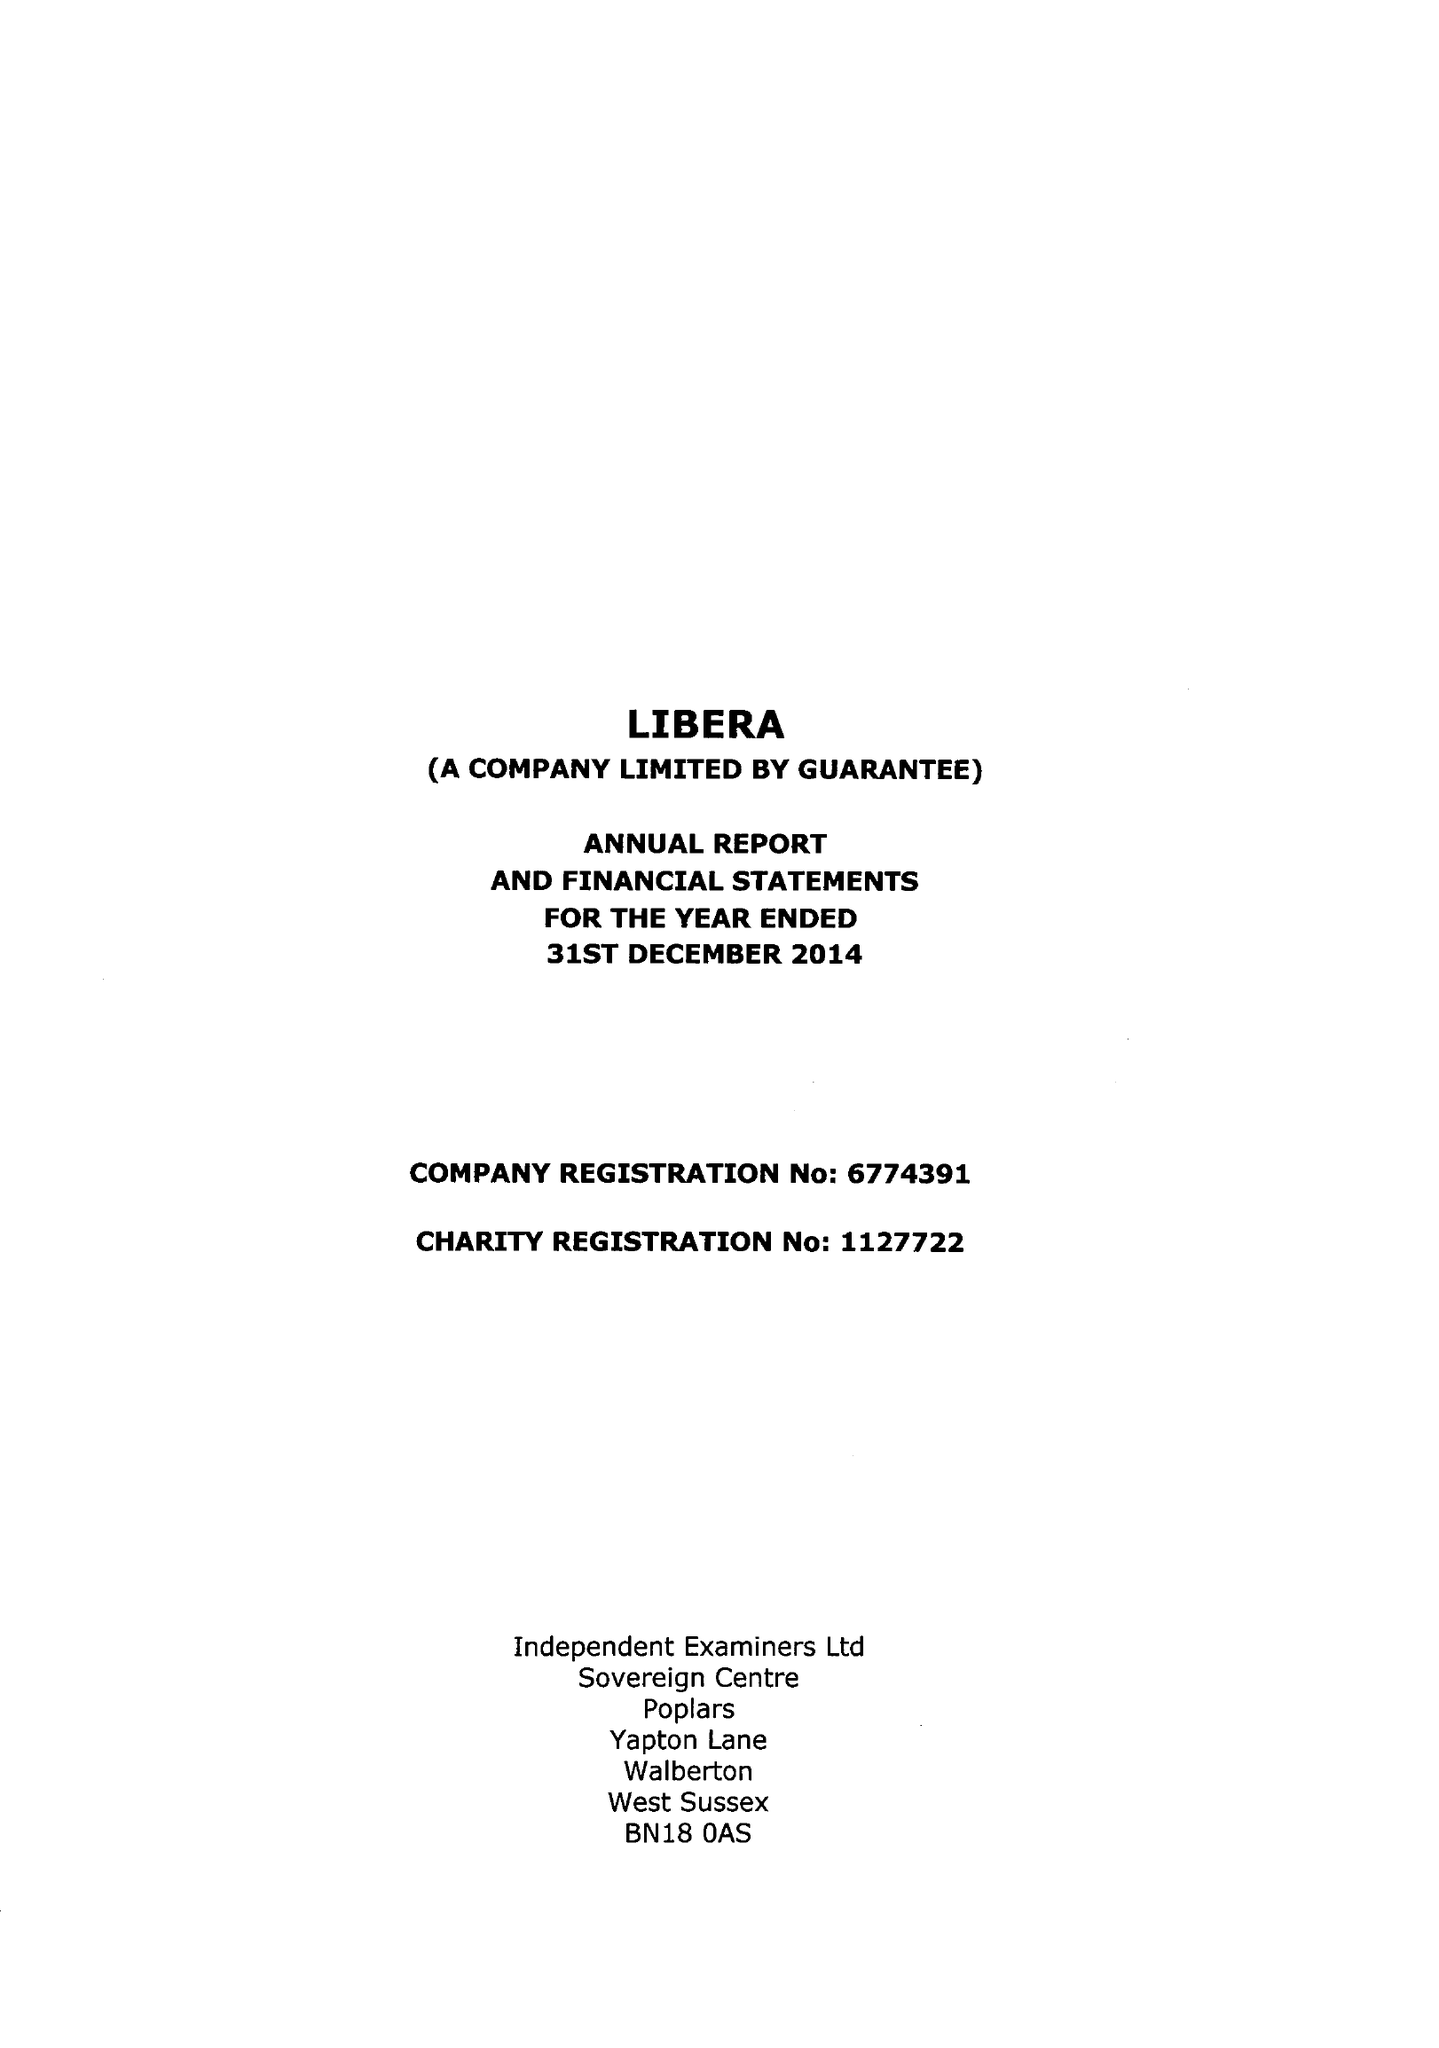What is the value for the address__post_town?
Answer the question using a single word or phrase. CROYDON 